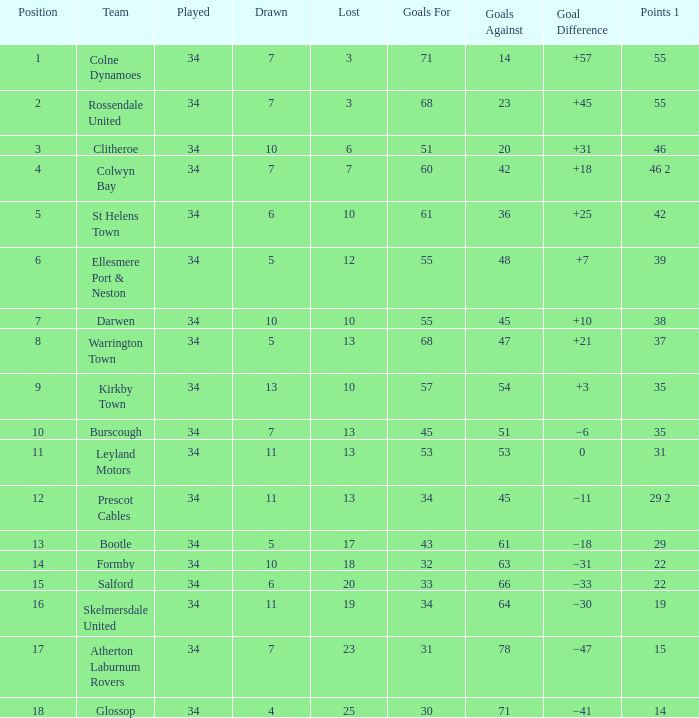Which Goals For has a Lost of 12, and a Played larger than 34? None. 